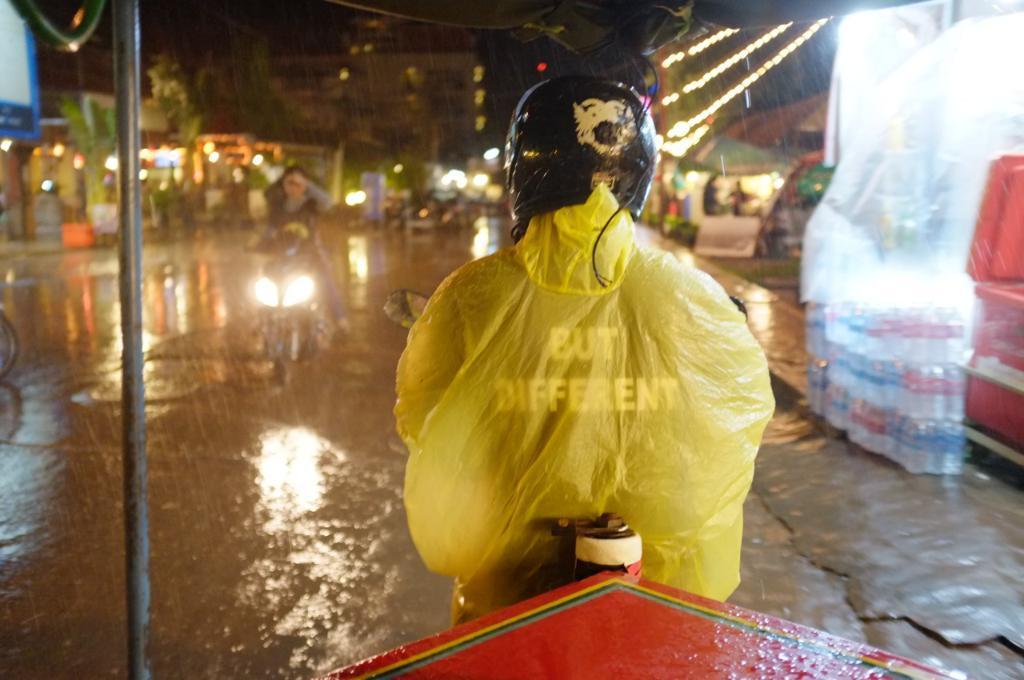Please provide a concise description of this image. In this image we can see people riding bikes. In the background there are buildings, trees and lights. On the right there is a store and we can see bottles. We can see a tent. 